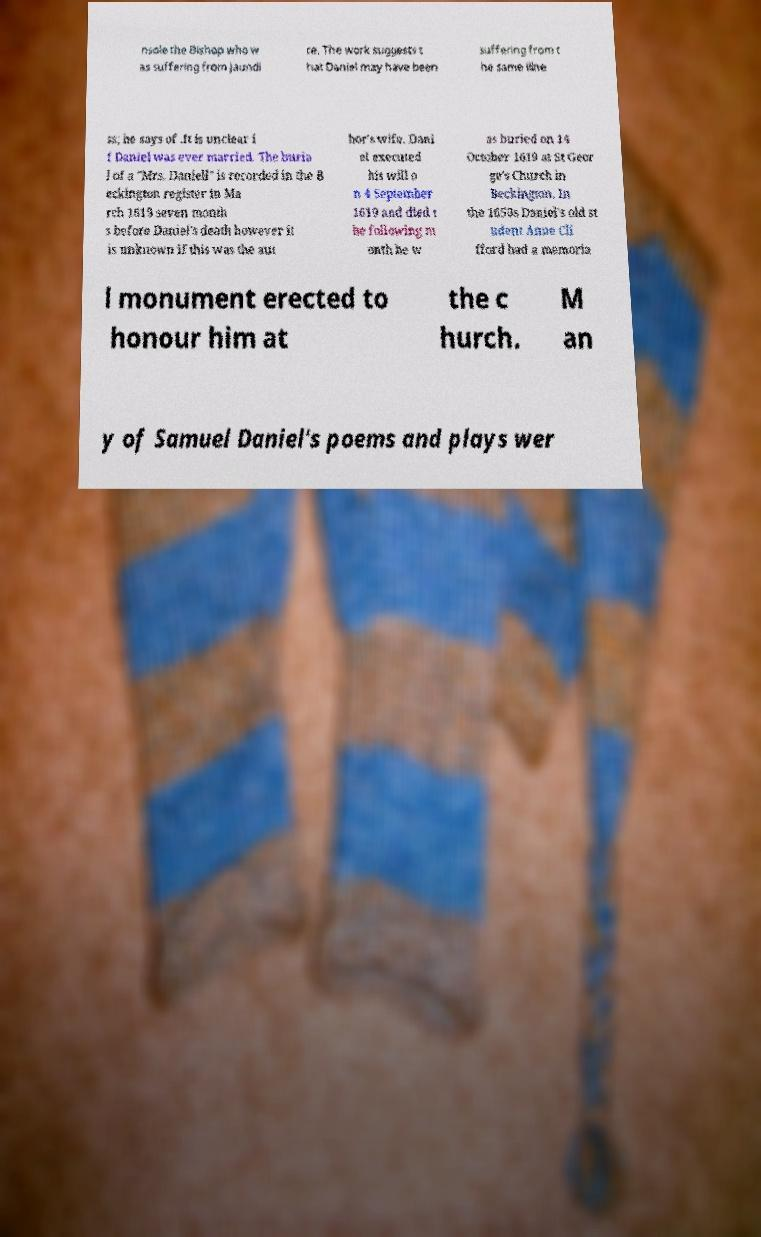Please identify and transcribe the text found in this image. nsole the Bishop who w as suffering from jaundi ce. The work suggests t hat Daniel may have been suffering from t he same illne ss; he says of .It is unclear i f Daniel was ever married. The buria l of a "Mrs. Daniell" is recorded in the B eckington register in Ma rch 1619 seven month s before Daniel's death however it is unknown if this was the aut hor's wife. Dani el executed his will o n 4 September 1619 and died t he following m onth he w as buried on 14 October 1619 at St Geor ge's Church in Beckington. In the 1650s Daniel's old st udent Anne Cli fford had a memoria l monument erected to honour him at the c hurch. M an y of Samuel Daniel's poems and plays wer 